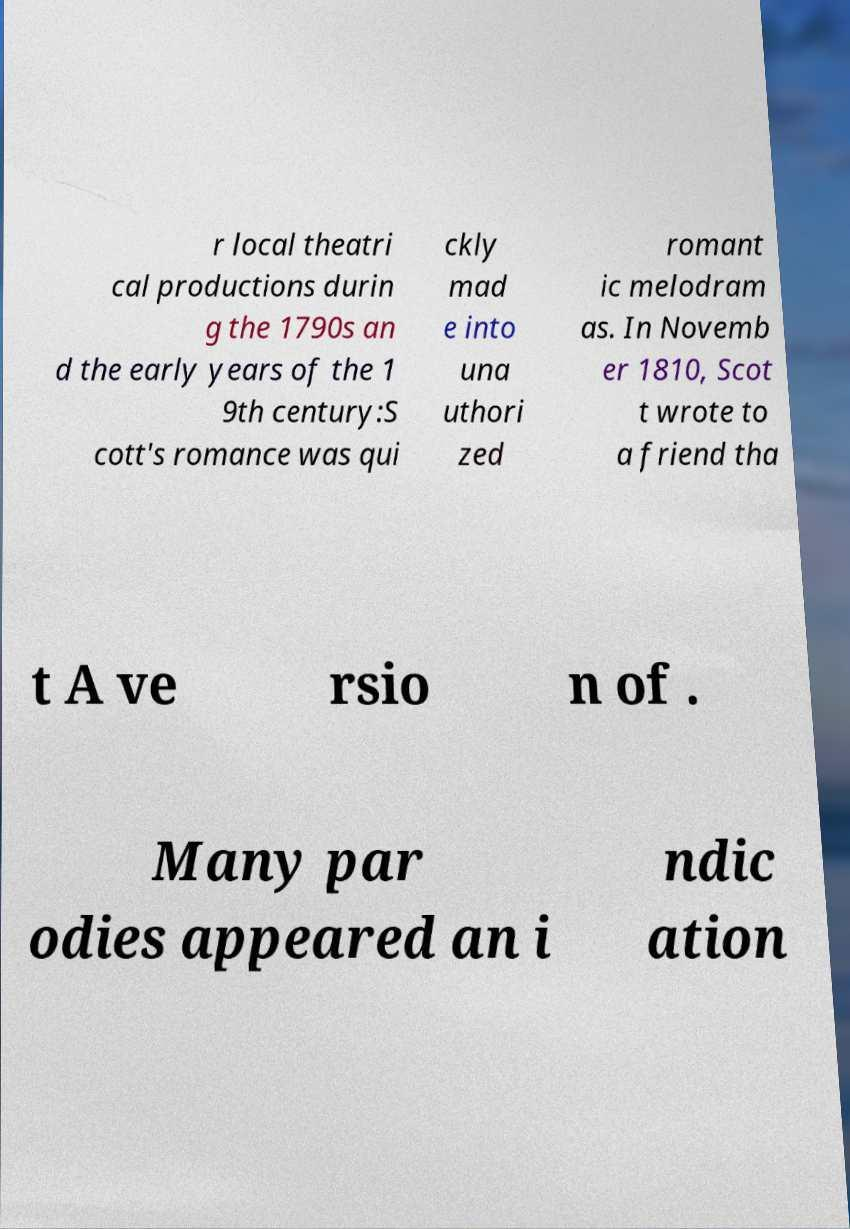Please read and relay the text visible in this image. What does it say? r local theatri cal productions durin g the 1790s an d the early years of the 1 9th century:S cott's romance was qui ckly mad e into una uthori zed romant ic melodram as. In Novemb er 1810, Scot t wrote to a friend tha t A ve rsio n of . Many par odies appeared an i ndic ation 